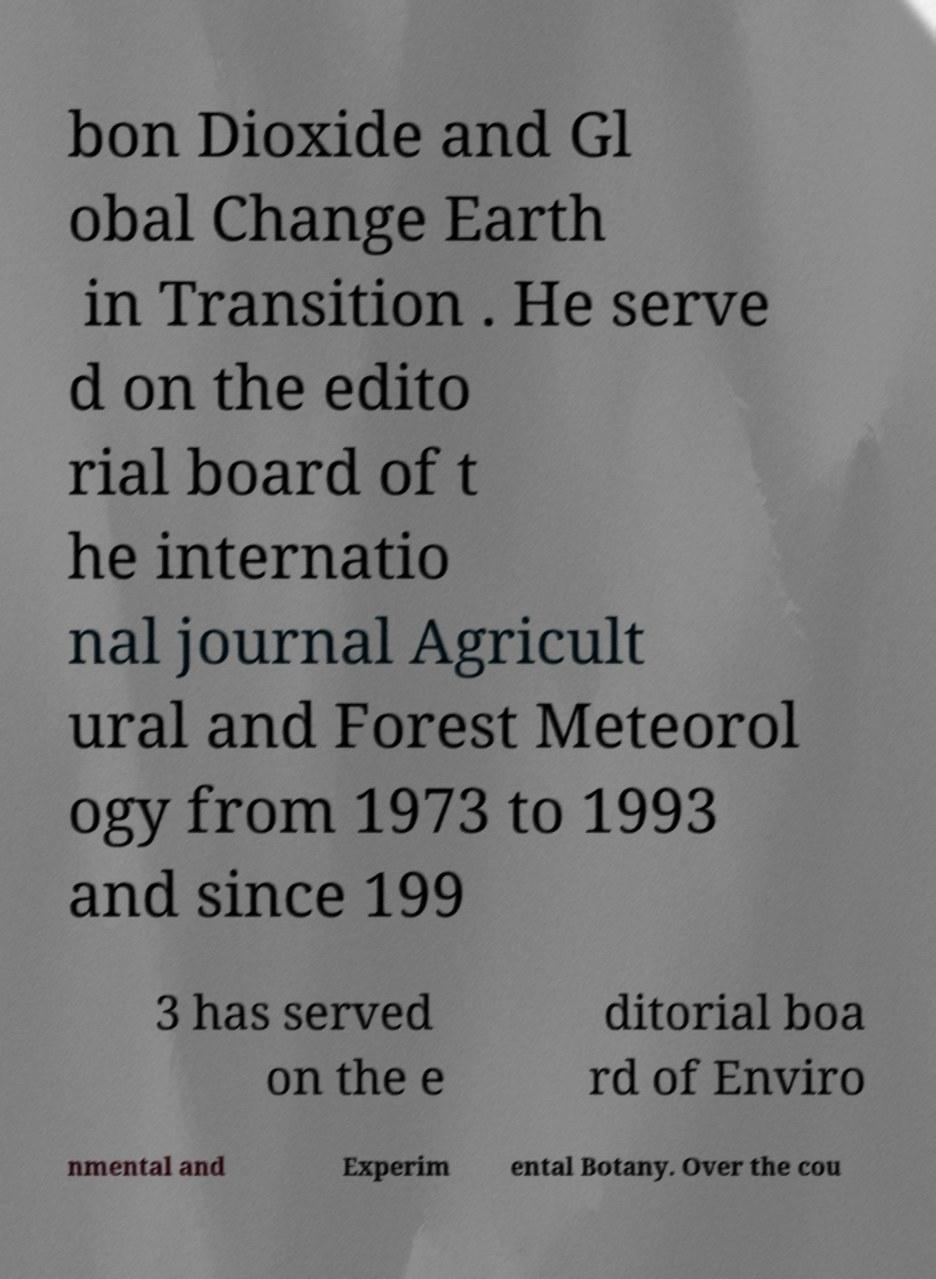What messages or text are displayed in this image? I need them in a readable, typed format. bon Dioxide and Gl obal Change Earth in Transition . He serve d on the edito rial board of t he internatio nal journal Agricult ural and Forest Meteorol ogy from 1973 to 1993 and since 199 3 has served on the e ditorial boa rd of Enviro nmental and Experim ental Botany. Over the cou 